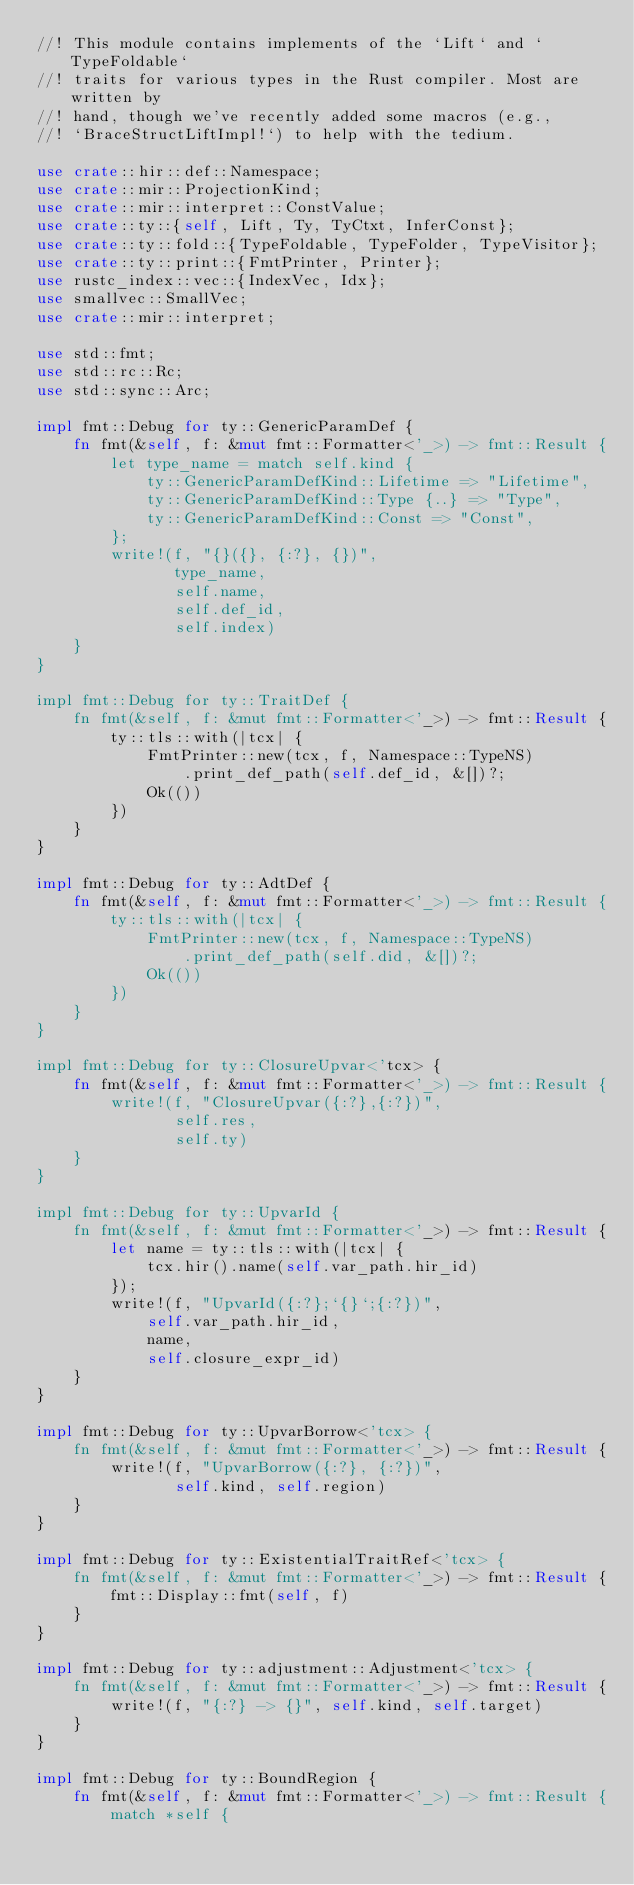<code> <loc_0><loc_0><loc_500><loc_500><_Rust_>//! This module contains implements of the `Lift` and `TypeFoldable`
//! traits for various types in the Rust compiler. Most are written by
//! hand, though we've recently added some macros (e.g.,
//! `BraceStructLiftImpl!`) to help with the tedium.

use crate::hir::def::Namespace;
use crate::mir::ProjectionKind;
use crate::mir::interpret::ConstValue;
use crate::ty::{self, Lift, Ty, TyCtxt, InferConst};
use crate::ty::fold::{TypeFoldable, TypeFolder, TypeVisitor};
use crate::ty::print::{FmtPrinter, Printer};
use rustc_index::vec::{IndexVec, Idx};
use smallvec::SmallVec;
use crate::mir::interpret;

use std::fmt;
use std::rc::Rc;
use std::sync::Arc;

impl fmt::Debug for ty::GenericParamDef {
    fn fmt(&self, f: &mut fmt::Formatter<'_>) -> fmt::Result {
        let type_name = match self.kind {
            ty::GenericParamDefKind::Lifetime => "Lifetime",
            ty::GenericParamDefKind::Type {..} => "Type",
            ty::GenericParamDefKind::Const => "Const",
        };
        write!(f, "{}({}, {:?}, {})",
               type_name,
               self.name,
               self.def_id,
               self.index)
    }
}

impl fmt::Debug for ty::TraitDef {
    fn fmt(&self, f: &mut fmt::Formatter<'_>) -> fmt::Result {
        ty::tls::with(|tcx| {
            FmtPrinter::new(tcx, f, Namespace::TypeNS)
                .print_def_path(self.def_id, &[])?;
            Ok(())
        })
    }
}

impl fmt::Debug for ty::AdtDef {
    fn fmt(&self, f: &mut fmt::Formatter<'_>) -> fmt::Result {
        ty::tls::with(|tcx| {
            FmtPrinter::new(tcx, f, Namespace::TypeNS)
                .print_def_path(self.did, &[])?;
            Ok(())
        })
    }
}

impl fmt::Debug for ty::ClosureUpvar<'tcx> {
    fn fmt(&self, f: &mut fmt::Formatter<'_>) -> fmt::Result {
        write!(f, "ClosureUpvar({:?},{:?})",
               self.res,
               self.ty)
    }
}

impl fmt::Debug for ty::UpvarId {
    fn fmt(&self, f: &mut fmt::Formatter<'_>) -> fmt::Result {
        let name = ty::tls::with(|tcx| {
            tcx.hir().name(self.var_path.hir_id)
        });
        write!(f, "UpvarId({:?};`{}`;{:?})",
            self.var_path.hir_id,
            name,
            self.closure_expr_id)
    }
}

impl fmt::Debug for ty::UpvarBorrow<'tcx> {
    fn fmt(&self, f: &mut fmt::Formatter<'_>) -> fmt::Result {
        write!(f, "UpvarBorrow({:?}, {:?})",
               self.kind, self.region)
    }
}

impl fmt::Debug for ty::ExistentialTraitRef<'tcx> {
    fn fmt(&self, f: &mut fmt::Formatter<'_>) -> fmt::Result {
        fmt::Display::fmt(self, f)
    }
}

impl fmt::Debug for ty::adjustment::Adjustment<'tcx> {
    fn fmt(&self, f: &mut fmt::Formatter<'_>) -> fmt::Result {
        write!(f, "{:?} -> {}", self.kind, self.target)
    }
}

impl fmt::Debug for ty::BoundRegion {
    fn fmt(&self, f: &mut fmt::Formatter<'_>) -> fmt::Result {
        match *self {</code> 